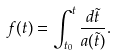<formula> <loc_0><loc_0><loc_500><loc_500>f ( t ) = \int _ { t _ { 0 } } ^ { t } \frac { d \tilde { t } } { a ( \tilde { t } ) } .</formula> 